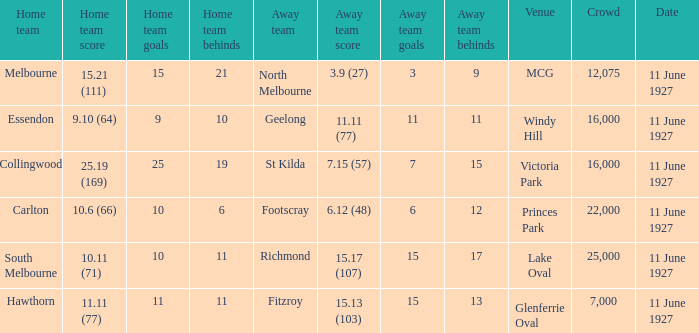When essendon was the home team, how many individuals were present in the crowd? 1.0. 